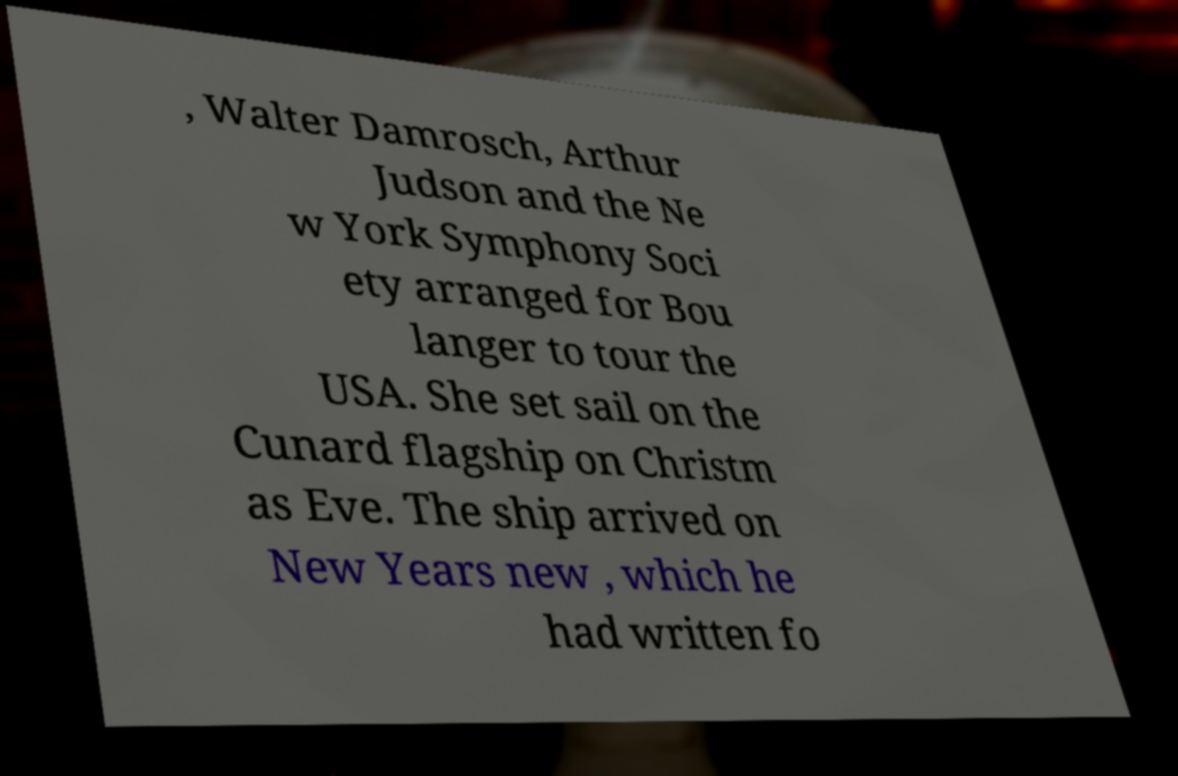Please identify and transcribe the text found in this image. , Walter Damrosch, Arthur Judson and the Ne w York Symphony Soci ety arranged for Bou langer to tour the USA. She set sail on the Cunard flagship on Christm as Eve. The ship arrived on New Years new , which he had written fo 